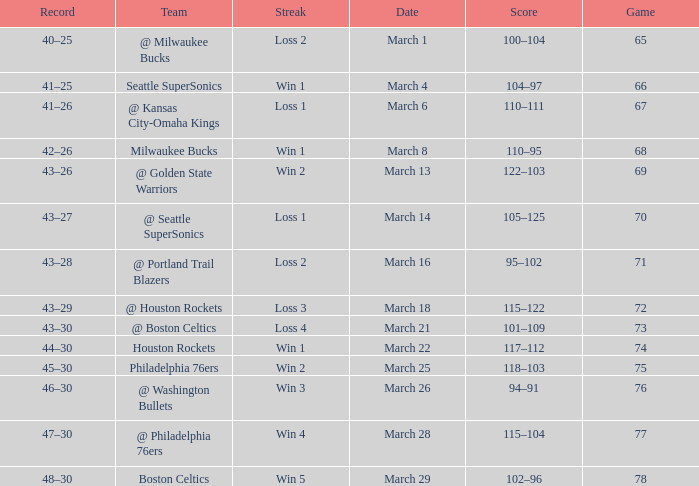What is Team, when Game is 77? @ Philadelphia 76ers. 